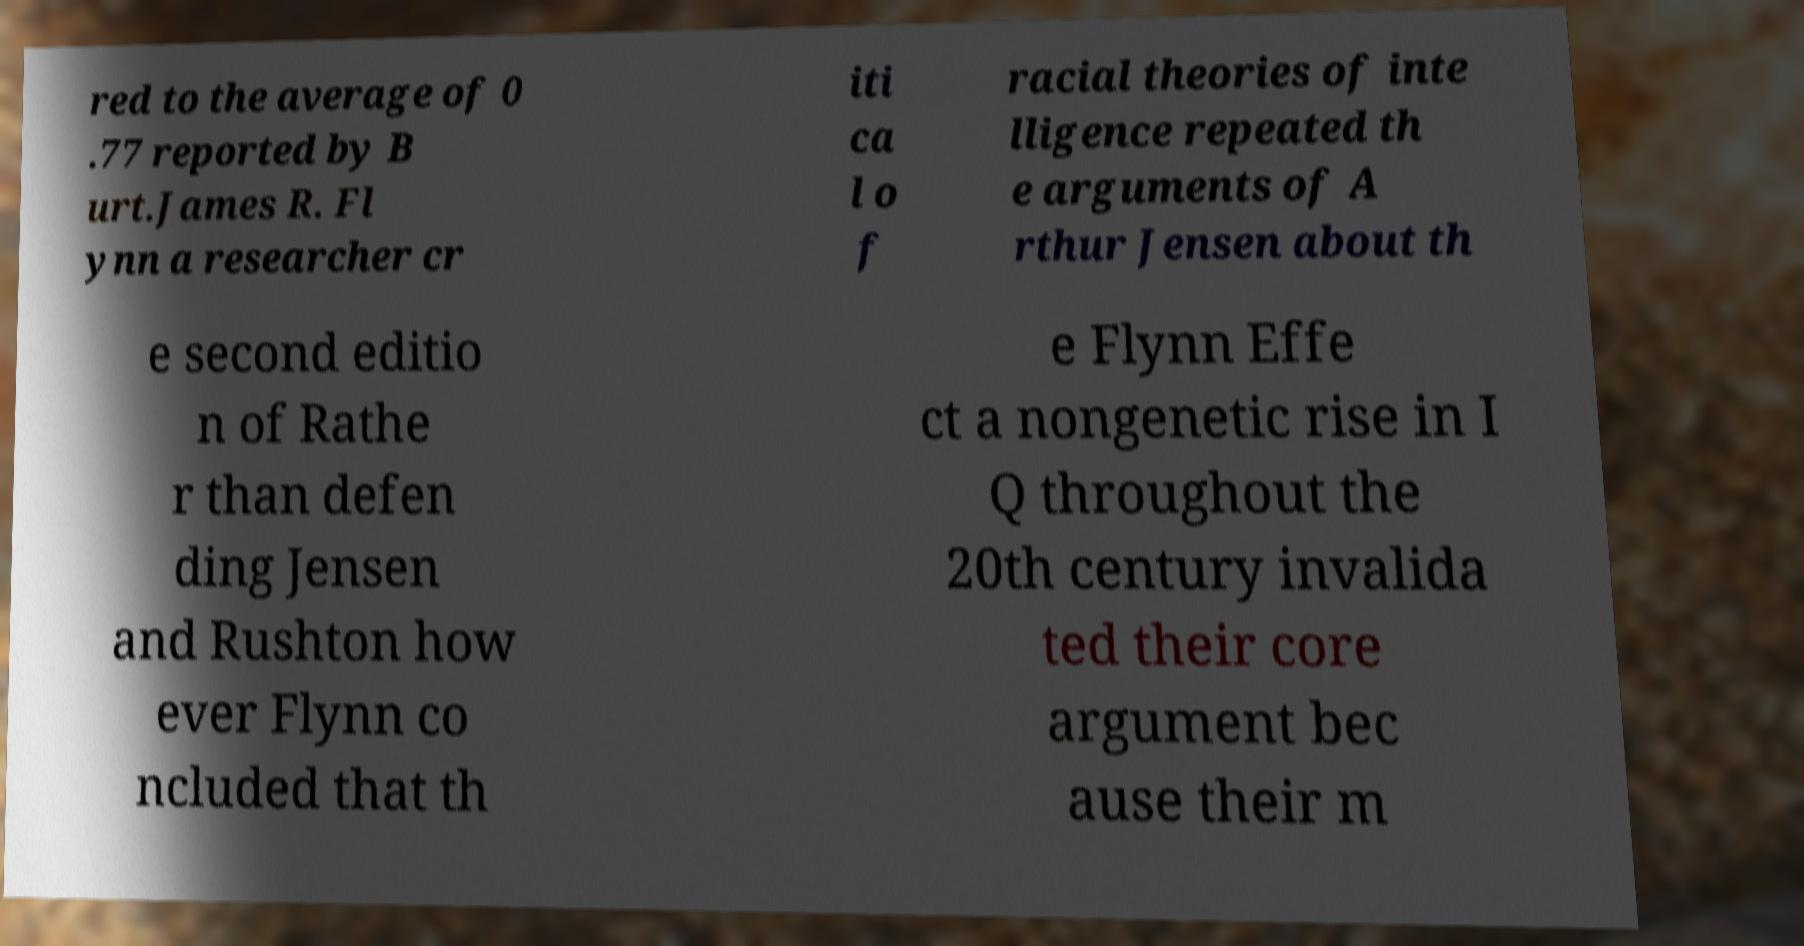Could you extract and type out the text from this image? red to the average of 0 .77 reported by B urt.James R. Fl ynn a researcher cr iti ca l o f racial theories of inte lligence repeated th e arguments of A rthur Jensen about th e second editio n of Rathe r than defen ding Jensen and Rushton how ever Flynn co ncluded that th e Flynn Effe ct a nongenetic rise in I Q throughout the 20th century invalida ted their core argument bec ause their m 